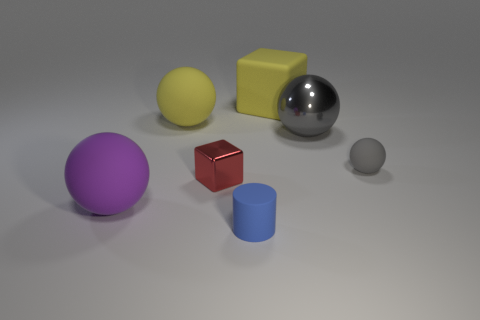Add 2 small red blocks. How many objects exist? 9 Subtract 2 blocks. How many blocks are left? 0 Subtract all red blocks. How many blocks are left? 1 Subtract all matte balls. How many balls are left? 1 Subtract all brown spheres. Subtract all green blocks. How many spheres are left? 4 Subtract all yellow spheres. How many cyan cylinders are left? 0 Subtract all purple cylinders. Subtract all tiny gray rubber things. How many objects are left? 6 Add 5 blue objects. How many blue objects are left? 6 Add 5 green metal things. How many green metal things exist? 5 Subtract 0 purple cubes. How many objects are left? 7 